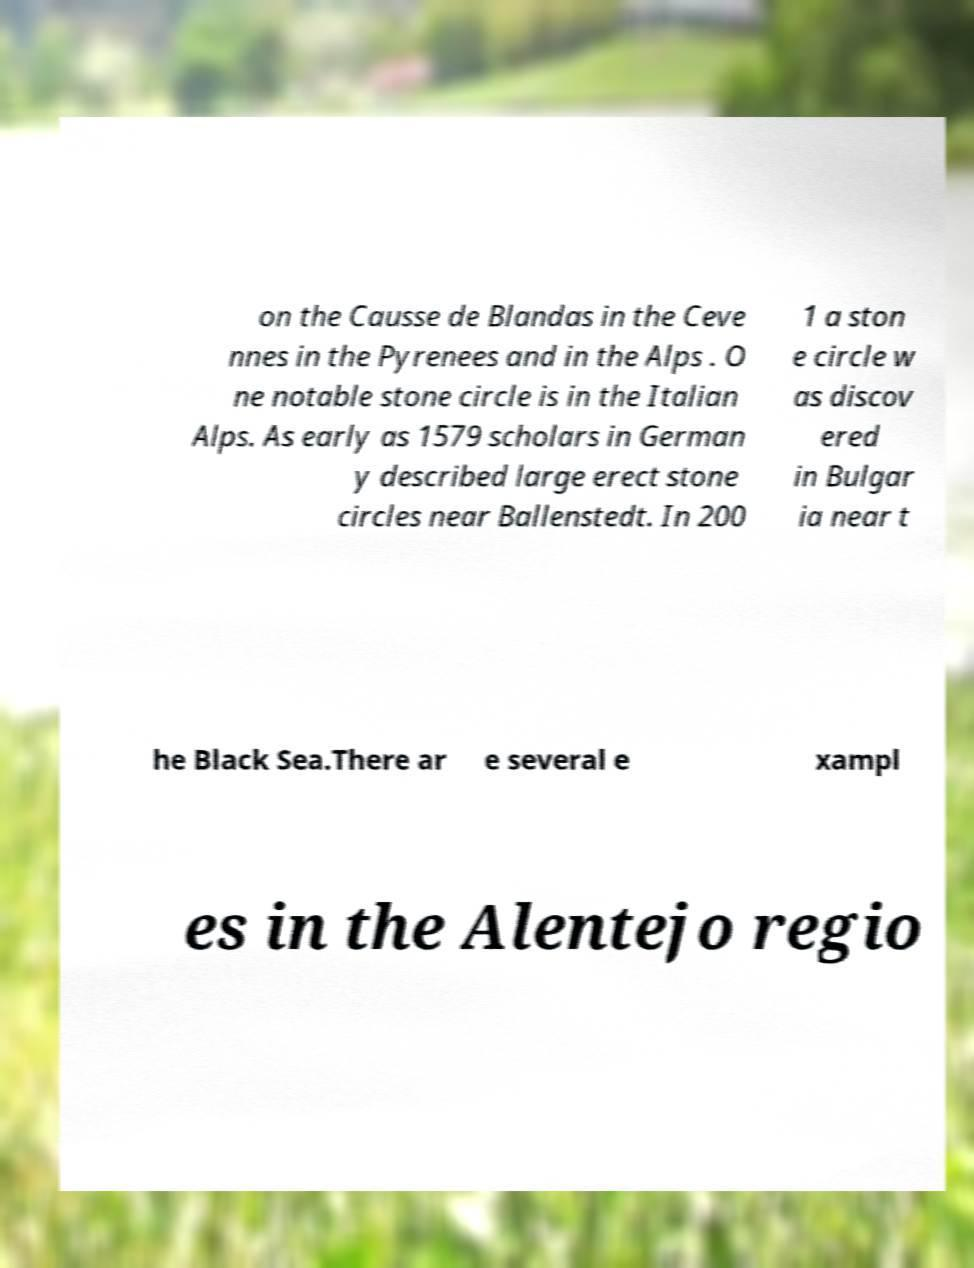What messages or text are displayed in this image? I need them in a readable, typed format. on the Causse de Blandas in the Ceve nnes in the Pyrenees and in the Alps . O ne notable stone circle is in the Italian Alps. As early as 1579 scholars in German y described large erect stone circles near Ballenstedt. In 200 1 a ston e circle w as discov ered in Bulgar ia near t he Black Sea.There ar e several e xampl es in the Alentejo regio 